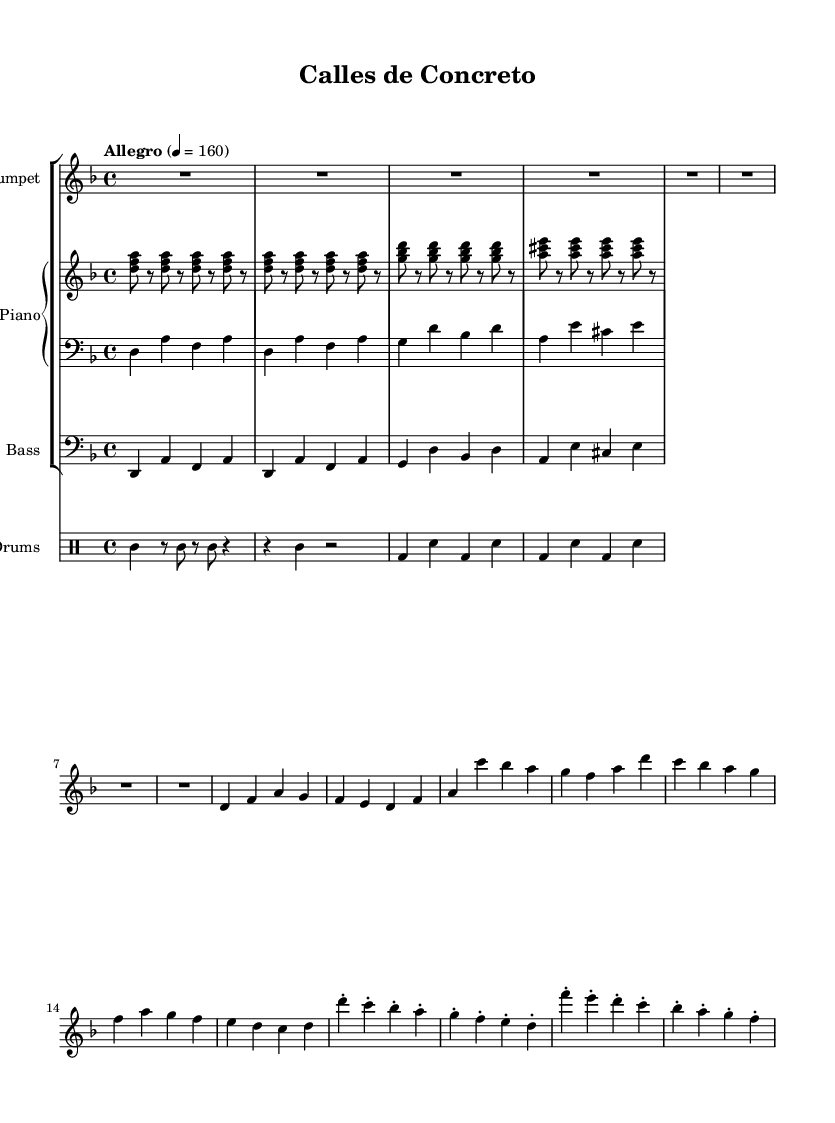What is the key signature of this music? The key signature is indicated at the beginning of the sheet music. In this case, there are two flats (B♭ and E♭) which corresponds to the key of D minor.
Answer: D minor What is the time signature of this music? The time signature appears at the beginning of the music. Here, it is indicated as 4/4, which means there are four beats per measure and the quarter note gets one beat.
Answer: 4/4 What is the tempo marking of this piece? The tempo marking, which indicates the speed of the piece, is presented as "Allegro" with a metronome marking of 160 beats per minute. This signifies a fast and lively tempo.
Answer: Allegro, 160 How many measures are there in the chorus section? By analyzing the chorus section, we can count the number of measures. The chorus consists of four distinct measures, each representing a separate musical idea.
Answer: 4 What rhythmic pattern is used for the drums? The drum part includes a clave pattern followed by conga and timbale patterns. We can identify the clave from its rhythmic arrangement over the first few measures.
Answer: Clave What type of chords are used in the piano's right hand? The right hand of the piano is using a simplified montuno pattern, characterized by the use of triads played in the higher register, typically representing the harmonic foundation of Salsa music.
Answer: Triads What does the title "Calles de Concreto" suggest about the theme of the piece? The title translates to "Concrete Streets," indicating a connection between the urban landscape and the music's inspiration, likely reflecting the rhythms and life seen in city planning and architecture.
Answer: Urban landscape 